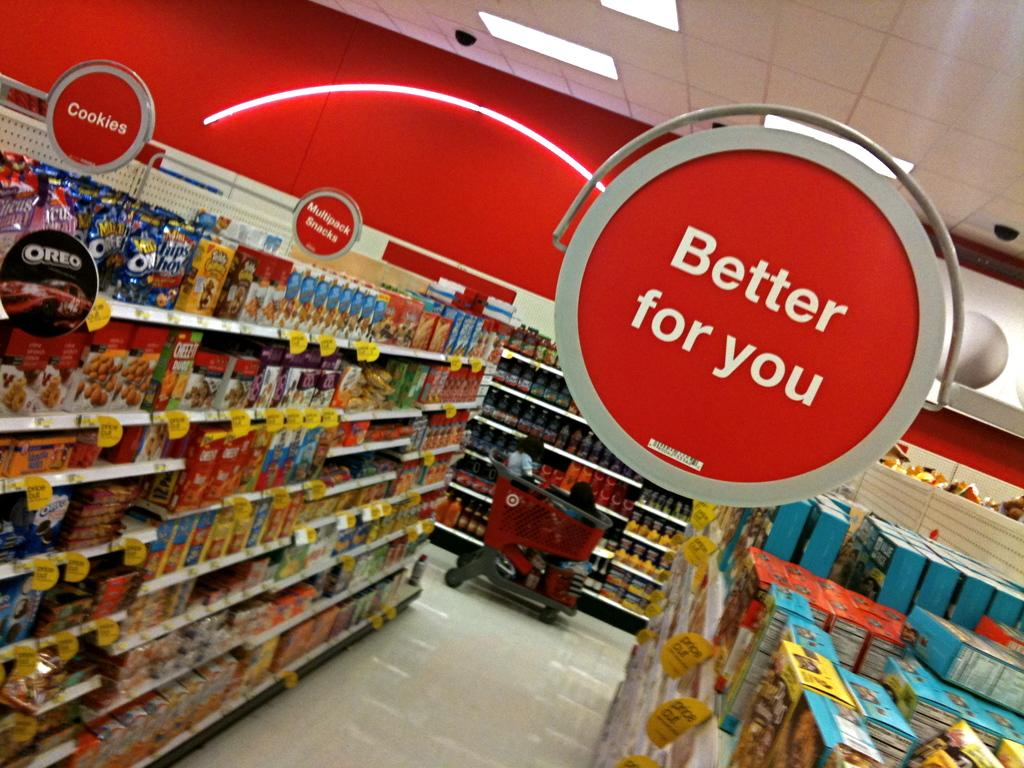<image>
Describe the image concisely. Red indoor sign that says "Better for you" is shown above cookies aisle. 